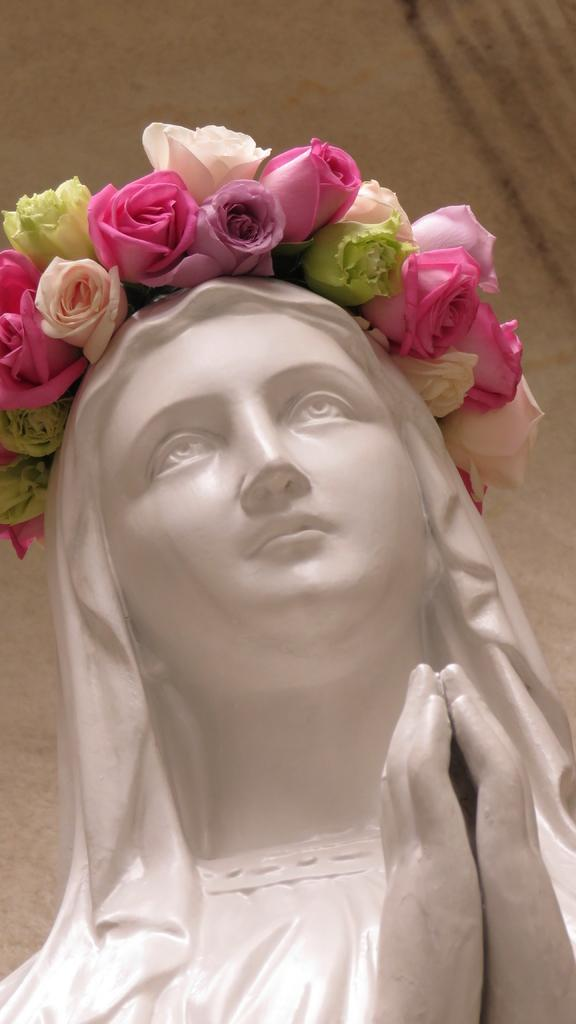What is the main subject of the image? The main subject of the image is a woman's statue. What color is the statue? The statue is in white color. What is the statue wearing on its head? The statue is wearing a flower crown. What is the statue doing with its hands? The statue has both hands joined together. What can be seen in the background of the image? There is a wall in the background of the image. What type of punishment is the actor receiving in the image? There is no actor or punishment present in the image; it features a statue of a woman. 